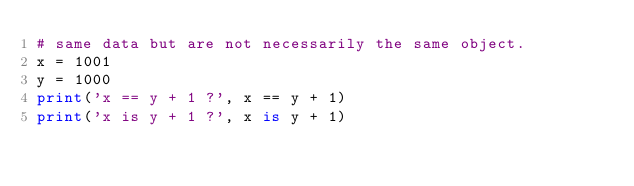Convert code to text. <code><loc_0><loc_0><loc_500><loc_500><_Python_># same data but are not necessarily the same object.
x = 1001
y = 1000
print('x == y + 1 ?', x == y + 1)
print('x is y + 1 ?', x is y + 1)
</code> 